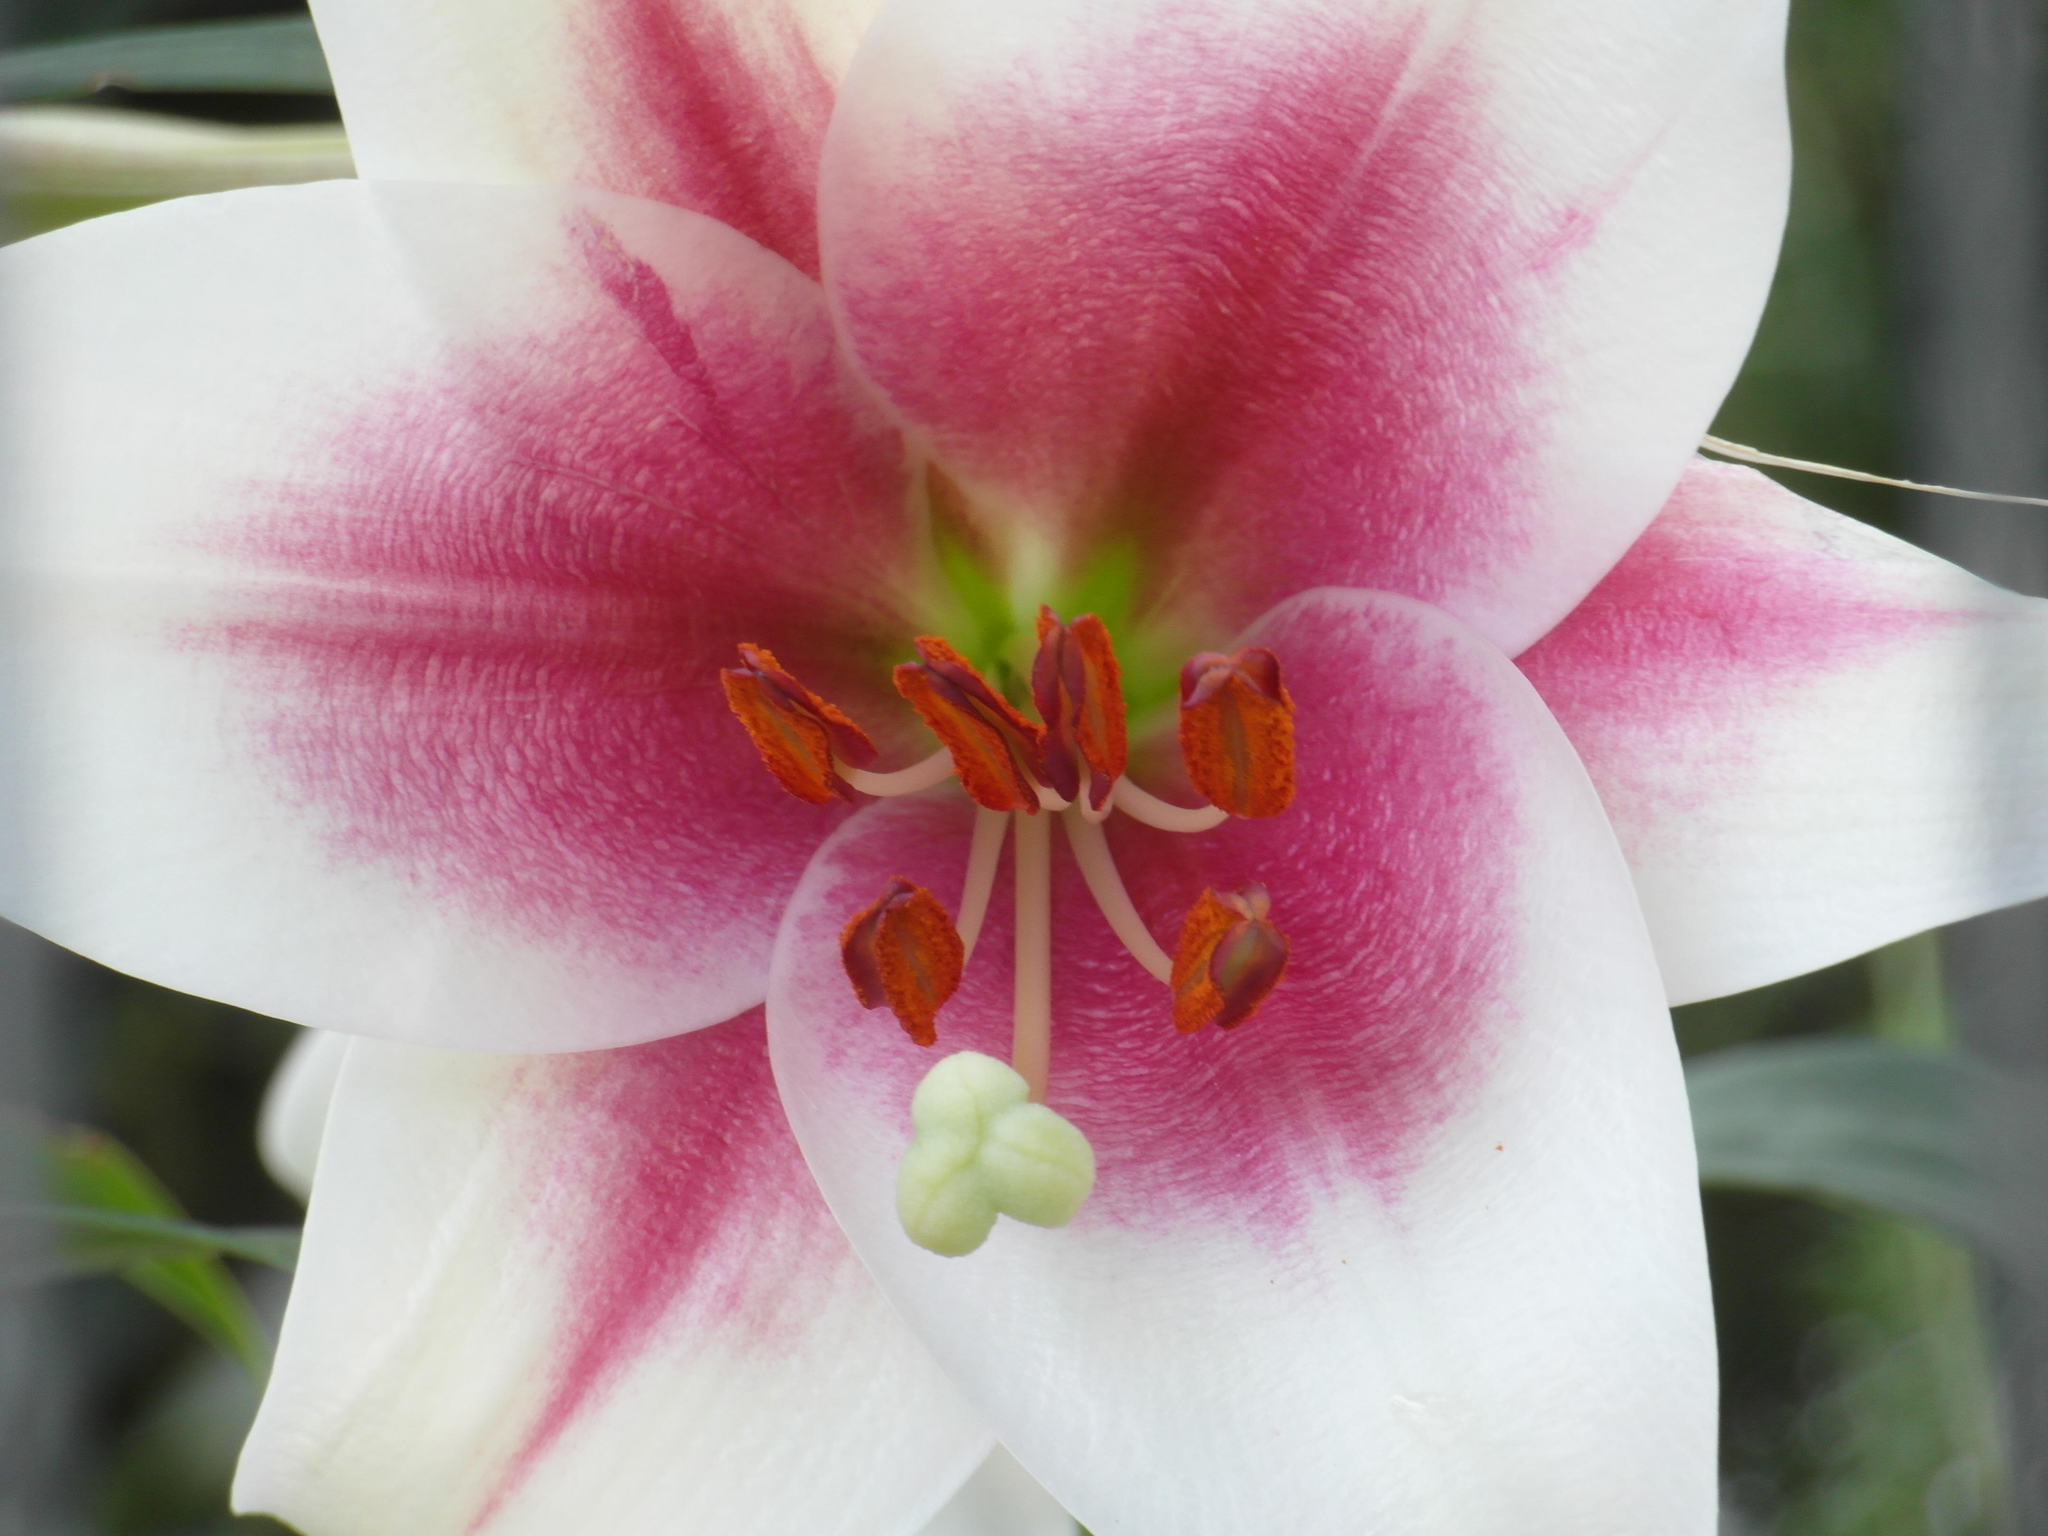What is the main subject of the image? There is a flower in the image. Can you describe the color of the flower? The flower has white and pink colors. What are the anthers on the flower used for? The anthers on the flower are used for pollination. What else can be seen in the image besides the flower? There are plants in the image. How would you describe the background of the image? The background of the image is blurred. What type of protest is happening in the image? There is no protest present in the image; it features a flower and plants. What is the occupation of the farmer in the image? There is no farmer present in the image. 